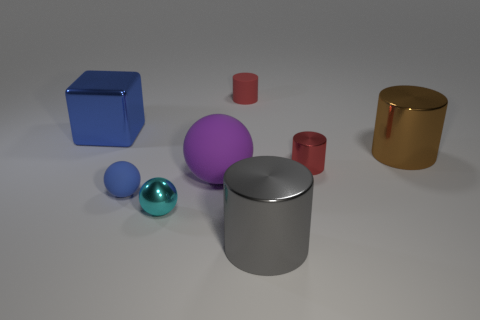There is another cylinder that is the same color as the tiny shiny cylinder; what is its size?
Give a very brief answer. Small. Is there a small shiny thing that has the same color as the matte cylinder?
Keep it short and to the point. Yes. What is the shape of the large metal object that is the same color as the tiny matte sphere?
Offer a very short reply. Cube. Are there any brown metal things that have the same shape as the red shiny thing?
Ensure brevity in your answer.  Yes. What shape is the purple thing that is the same size as the gray cylinder?
Your answer should be compact. Sphere. Are there any red matte cylinders that have the same size as the cube?
Keep it short and to the point. No. There is another tiny object that is made of the same material as the small blue object; what is its color?
Your response must be concise. Red. What number of big rubber spheres are behind the metal cylinder that is in front of the purple rubber sphere?
Keep it short and to the point. 1. The small thing that is left of the large gray object and behind the large ball is made of what material?
Your answer should be compact. Rubber. There is a object to the left of the blue ball; is its shape the same as the large purple thing?
Offer a very short reply. No. 